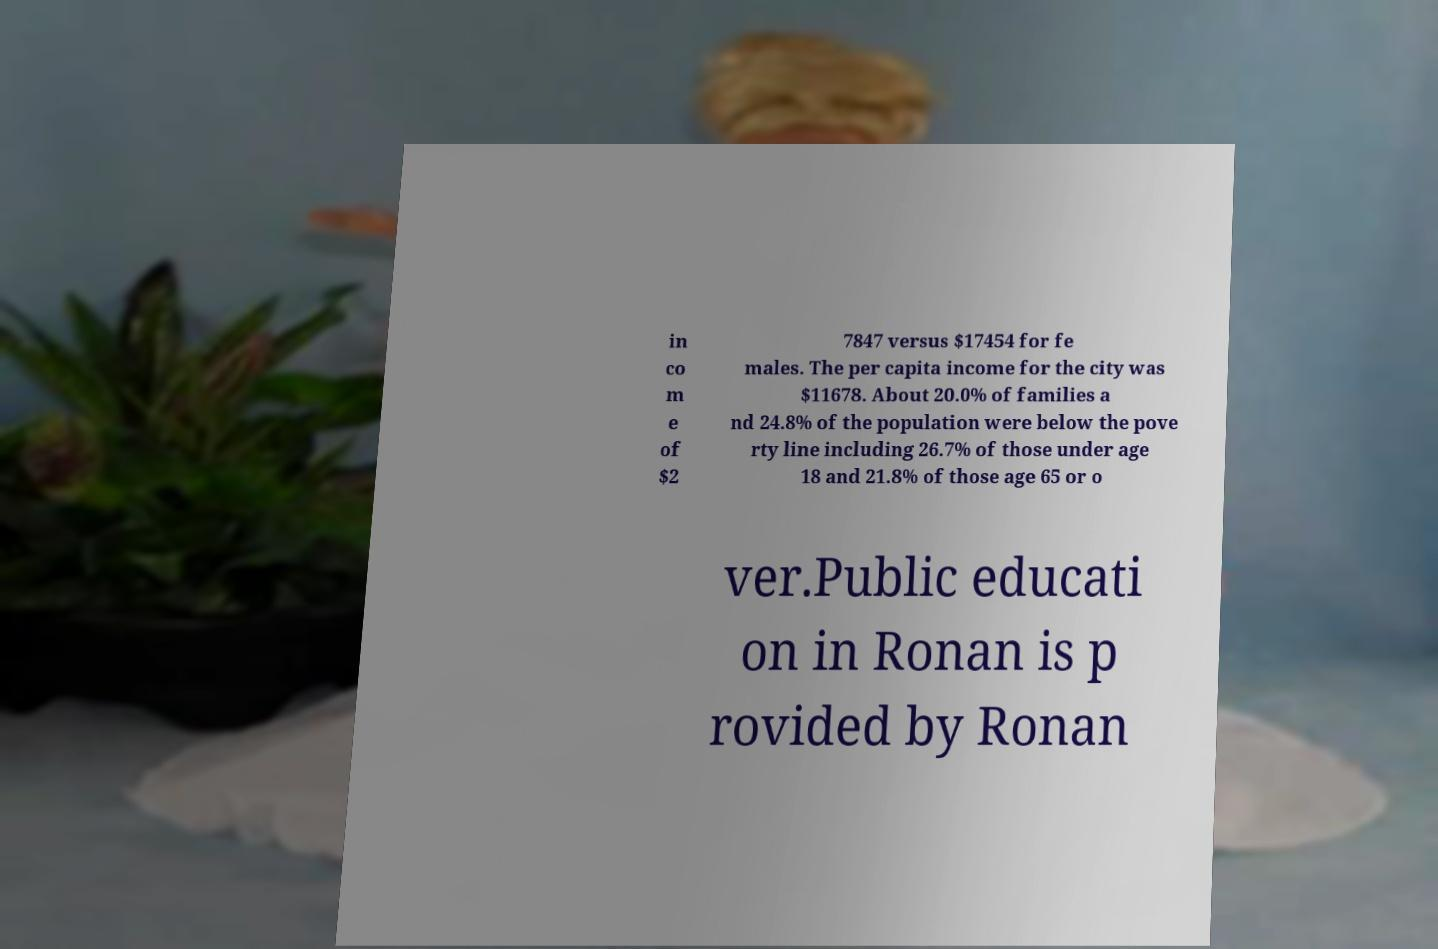Please read and relay the text visible in this image. What does it say? in co m e of $2 7847 versus $17454 for fe males. The per capita income for the city was $11678. About 20.0% of families a nd 24.8% of the population were below the pove rty line including 26.7% of those under age 18 and 21.8% of those age 65 or o ver.Public educati on in Ronan is p rovided by Ronan 